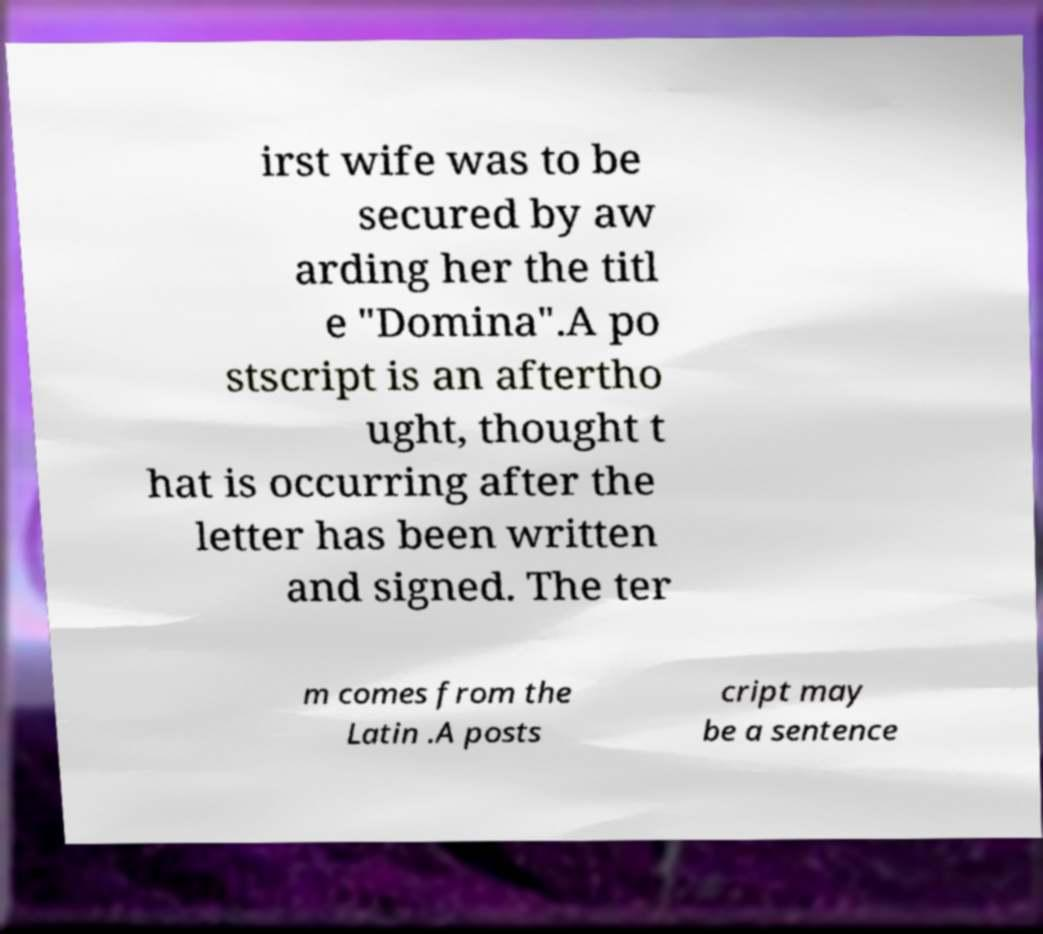Could you assist in decoding the text presented in this image and type it out clearly? irst wife was to be secured by aw arding her the titl e "Domina".A po stscript is an aftertho ught, thought t hat is occurring after the letter has been written and signed. The ter m comes from the Latin .A posts cript may be a sentence 